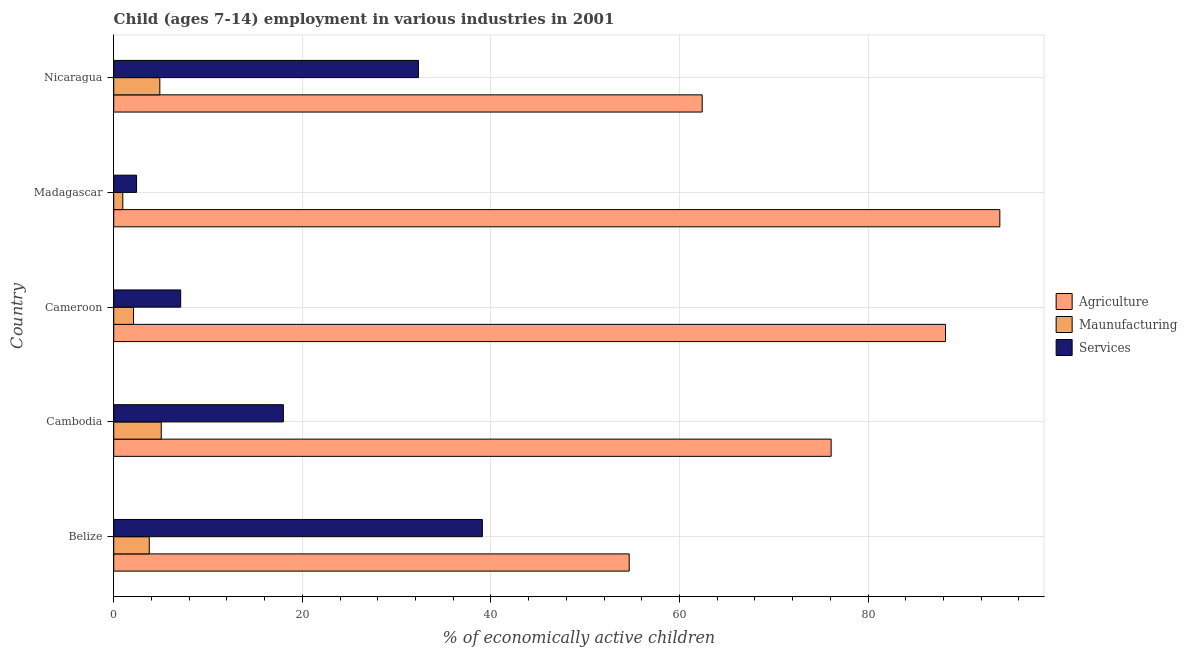Are the number of bars per tick equal to the number of legend labels?
Give a very brief answer. Yes. What is the label of the 2nd group of bars from the top?
Give a very brief answer. Madagascar. What is the percentage of economically active children in services in Belize?
Your response must be concise. 39.09. Across all countries, what is the maximum percentage of economically active children in manufacturing?
Offer a terse response. 5.04. Across all countries, what is the minimum percentage of economically active children in agriculture?
Your answer should be compact. 54.66. In which country was the percentage of economically active children in agriculture maximum?
Provide a succinct answer. Madagascar. In which country was the percentage of economically active children in manufacturing minimum?
Your answer should be very brief. Madagascar. What is the total percentage of economically active children in agriculture in the graph?
Keep it short and to the point. 375.33. What is the difference between the percentage of economically active children in agriculture in Belize and that in Nicaragua?
Give a very brief answer. -7.74. What is the difference between the percentage of economically active children in manufacturing in Cambodia and the percentage of economically active children in agriculture in Belize?
Ensure brevity in your answer.  -49.62. What is the average percentage of economically active children in agriculture per country?
Ensure brevity in your answer.  75.07. What is the difference between the percentage of economically active children in agriculture and percentage of economically active children in manufacturing in Cambodia?
Your response must be concise. 71.04. In how many countries, is the percentage of economically active children in services greater than 24 %?
Keep it short and to the point. 2. What is the ratio of the percentage of economically active children in agriculture in Cambodia to that in Nicaragua?
Make the answer very short. 1.22. Is the percentage of economically active children in manufacturing in Cambodia less than that in Cameroon?
Offer a terse response. No. What is the difference between the highest and the second highest percentage of economically active children in manufacturing?
Keep it short and to the point. 0.15. What is the difference between the highest and the lowest percentage of economically active children in agriculture?
Make the answer very short. 39.31. In how many countries, is the percentage of economically active children in manufacturing greater than the average percentage of economically active children in manufacturing taken over all countries?
Your answer should be compact. 3. Is the sum of the percentage of economically active children in agriculture in Belize and Nicaragua greater than the maximum percentage of economically active children in manufacturing across all countries?
Keep it short and to the point. Yes. What does the 2nd bar from the top in Cameroon represents?
Provide a short and direct response. Maunufacturing. What does the 1st bar from the bottom in Cambodia represents?
Give a very brief answer. Agriculture. Are all the bars in the graph horizontal?
Provide a short and direct response. Yes. How many countries are there in the graph?
Offer a terse response. 5. Does the graph contain any zero values?
Your answer should be compact. No. Does the graph contain grids?
Provide a short and direct response. Yes. How many legend labels are there?
Your answer should be very brief. 3. What is the title of the graph?
Ensure brevity in your answer.  Child (ages 7-14) employment in various industries in 2001. Does "Labor Market" appear as one of the legend labels in the graph?
Provide a succinct answer. No. What is the label or title of the X-axis?
Offer a very short reply. % of economically active children. What is the label or title of the Y-axis?
Offer a terse response. Country. What is the % of economically active children of Agriculture in Belize?
Offer a very short reply. 54.66. What is the % of economically active children of Maunufacturing in Belize?
Keep it short and to the point. 3.77. What is the % of economically active children of Services in Belize?
Provide a succinct answer. 39.09. What is the % of economically active children of Agriculture in Cambodia?
Provide a short and direct response. 76.08. What is the % of economically active children of Maunufacturing in Cambodia?
Give a very brief answer. 5.04. What is the % of economically active children in Services in Cambodia?
Offer a very short reply. 17.99. What is the % of economically active children of Agriculture in Cameroon?
Give a very brief answer. 88.21. What is the % of economically active children of Services in Cameroon?
Offer a terse response. 7.1. What is the % of economically active children of Agriculture in Madagascar?
Provide a short and direct response. 93.97. What is the % of economically active children of Services in Madagascar?
Give a very brief answer. 2.42. What is the % of economically active children in Agriculture in Nicaragua?
Make the answer very short. 62.41. What is the % of economically active children in Maunufacturing in Nicaragua?
Offer a very short reply. 4.89. What is the % of economically active children in Services in Nicaragua?
Your response must be concise. 32.31. Across all countries, what is the maximum % of economically active children of Agriculture?
Your answer should be very brief. 93.97. Across all countries, what is the maximum % of economically active children in Maunufacturing?
Your answer should be very brief. 5.04. Across all countries, what is the maximum % of economically active children in Services?
Your response must be concise. 39.09. Across all countries, what is the minimum % of economically active children of Agriculture?
Your answer should be very brief. 54.66. Across all countries, what is the minimum % of economically active children of Maunufacturing?
Keep it short and to the point. 0.96. Across all countries, what is the minimum % of economically active children of Services?
Offer a very short reply. 2.42. What is the total % of economically active children in Agriculture in the graph?
Your answer should be compact. 375.33. What is the total % of economically active children in Maunufacturing in the graph?
Offer a very short reply. 16.76. What is the total % of economically active children of Services in the graph?
Your answer should be very brief. 98.92. What is the difference between the % of economically active children in Agriculture in Belize and that in Cambodia?
Your response must be concise. -21.42. What is the difference between the % of economically active children in Maunufacturing in Belize and that in Cambodia?
Provide a succinct answer. -1.27. What is the difference between the % of economically active children of Services in Belize and that in Cambodia?
Keep it short and to the point. 21.1. What is the difference between the % of economically active children in Agriculture in Belize and that in Cameroon?
Your answer should be very brief. -33.55. What is the difference between the % of economically active children in Maunufacturing in Belize and that in Cameroon?
Your response must be concise. 1.67. What is the difference between the % of economically active children in Services in Belize and that in Cameroon?
Ensure brevity in your answer.  31.99. What is the difference between the % of economically active children of Agriculture in Belize and that in Madagascar?
Keep it short and to the point. -39.31. What is the difference between the % of economically active children in Maunufacturing in Belize and that in Madagascar?
Make the answer very short. 2.81. What is the difference between the % of economically active children in Services in Belize and that in Madagascar?
Make the answer very short. 36.67. What is the difference between the % of economically active children of Agriculture in Belize and that in Nicaragua?
Your answer should be compact. -7.74. What is the difference between the % of economically active children in Maunufacturing in Belize and that in Nicaragua?
Your answer should be compact. -1.12. What is the difference between the % of economically active children in Services in Belize and that in Nicaragua?
Keep it short and to the point. 6.78. What is the difference between the % of economically active children in Agriculture in Cambodia and that in Cameroon?
Offer a terse response. -12.13. What is the difference between the % of economically active children of Maunufacturing in Cambodia and that in Cameroon?
Provide a succinct answer. 2.94. What is the difference between the % of economically active children in Services in Cambodia and that in Cameroon?
Provide a succinct answer. 10.89. What is the difference between the % of economically active children in Agriculture in Cambodia and that in Madagascar?
Give a very brief answer. -17.89. What is the difference between the % of economically active children of Maunufacturing in Cambodia and that in Madagascar?
Give a very brief answer. 4.08. What is the difference between the % of economically active children of Services in Cambodia and that in Madagascar?
Keep it short and to the point. 15.57. What is the difference between the % of economically active children in Agriculture in Cambodia and that in Nicaragua?
Offer a very short reply. 13.67. What is the difference between the % of economically active children in Maunufacturing in Cambodia and that in Nicaragua?
Ensure brevity in your answer.  0.15. What is the difference between the % of economically active children of Services in Cambodia and that in Nicaragua?
Offer a very short reply. -14.32. What is the difference between the % of economically active children in Agriculture in Cameroon and that in Madagascar?
Your answer should be compact. -5.76. What is the difference between the % of economically active children in Maunufacturing in Cameroon and that in Madagascar?
Your response must be concise. 1.14. What is the difference between the % of economically active children of Services in Cameroon and that in Madagascar?
Your response must be concise. 4.68. What is the difference between the % of economically active children of Agriculture in Cameroon and that in Nicaragua?
Your answer should be very brief. 25.8. What is the difference between the % of economically active children of Maunufacturing in Cameroon and that in Nicaragua?
Provide a succinct answer. -2.79. What is the difference between the % of economically active children in Services in Cameroon and that in Nicaragua?
Keep it short and to the point. -25.21. What is the difference between the % of economically active children in Agriculture in Madagascar and that in Nicaragua?
Provide a succinct answer. 31.56. What is the difference between the % of economically active children of Maunufacturing in Madagascar and that in Nicaragua?
Make the answer very short. -3.93. What is the difference between the % of economically active children of Services in Madagascar and that in Nicaragua?
Your answer should be very brief. -29.89. What is the difference between the % of economically active children in Agriculture in Belize and the % of economically active children in Maunufacturing in Cambodia?
Provide a short and direct response. 49.62. What is the difference between the % of economically active children of Agriculture in Belize and the % of economically active children of Services in Cambodia?
Provide a short and direct response. 36.67. What is the difference between the % of economically active children in Maunufacturing in Belize and the % of economically active children in Services in Cambodia?
Provide a short and direct response. -14.22. What is the difference between the % of economically active children of Agriculture in Belize and the % of economically active children of Maunufacturing in Cameroon?
Provide a short and direct response. 52.56. What is the difference between the % of economically active children of Agriculture in Belize and the % of economically active children of Services in Cameroon?
Provide a succinct answer. 47.56. What is the difference between the % of economically active children in Maunufacturing in Belize and the % of economically active children in Services in Cameroon?
Your response must be concise. -3.33. What is the difference between the % of economically active children of Agriculture in Belize and the % of economically active children of Maunufacturing in Madagascar?
Keep it short and to the point. 53.7. What is the difference between the % of economically active children in Agriculture in Belize and the % of economically active children in Services in Madagascar?
Provide a succinct answer. 52.24. What is the difference between the % of economically active children in Maunufacturing in Belize and the % of economically active children in Services in Madagascar?
Make the answer very short. 1.35. What is the difference between the % of economically active children of Agriculture in Belize and the % of economically active children of Maunufacturing in Nicaragua?
Give a very brief answer. 49.78. What is the difference between the % of economically active children in Agriculture in Belize and the % of economically active children in Services in Nicaragua?
Offer a terse response. 22.35. What is the difference between the % of economically active children of Maunufacturing in Belize and the % of economically active children of Services in Nicaragua?
Offer a very short reply. -28.54. What is the difference between the % of economically active children of Agriculture in Cambodia and the % of economically active children of Maunufacturing in Cameroon?
Ensure brevity in your answer.  73.98. What is the difference between the % of economically active children of Agriculture in Cambodia and the % of economically active children of Services in Cameroon?
Your answer should be compact. 68.98. What is the difference between the % of economically active children in Maunufacturing in Cambodia and the % of economically active children in Services in Cameroon?
Provide a short and direct response. -2.06. What is the difference between the % of economically active children of Agriculture in Cambodia and the % of economically active children of Maunufacturing in Madagascar?
Your answer should be very brief. 75.12. What is the difference between the % of economically active children of Agriculture in Cambodia and the % of economically active children of Services in Madagascar?
Provide a short and direct response. 73.66. What is the difference between the % of economically active children in Maunufacturing in Cambodia and the % of economically active children in Services in Madagascar?
Your answer should be very brief. 2.62. What is the difference between the % of economically active children of Agriculture in Cambodia and the % of economically active children of Maunufacturing in Nicaragua?
Keep it short and to the point. 71.19. What is the difference between the % of economically active children of Agriculture in Cambodia and the % of economically active children of Services in Nicaragua?
Your response must be concise. 43.77. What is the difference between the % of economically active children of Maunufacturing in Cambodia and the % of economically active children of Services in Nicaragua?
Make the answer very short. -27.27. What is the difference between the % of economically active children in Agriculture in Cameroon and the % of economically active children in Maunufacturing in Madagascar?
Give a very brief answer. 87.25. What is the difference between the % of economically active children in Agriculture in Cameroon and the % of economically active children in Services in Madagascar?
Provide a succinct answer. 85.79. What is the difference between the % of economically active children in Maunufacturing in Cameroon and the % of economically active children in Services in Madagascar?
Provide a short and direct response. -0.32. What is the difference between the % of economically active children of Agriculture in Cameroon and the % of economically active children of Maunufacturing in Nicaragua?
Your answer should be compact. 83.32. What is the difference between the % of economically active children of Agriculture in Cameroon and the % of economically active children of Services in Nicaragua?
Provide a short and direct response. 55.9. What is the difference between the % of economically active children in Maunufacturing in Cameroon and the % of economically active children in Services in Nicaragua?
Provide a short and direct response. -30.21. What is the difference between the % of economically active children in Agriculture in Madagascar and the % of economically active children in Maunufacturing in Nicaragua?
Offer a terse response. 89.08. What is the difference between the % of economically active children in Agriculture in Madagascar and the % of economically active children in Services in Nicaragua?
Provide a succinct answer. 61.66. What is the difference between the % of economically active children of Maunufacturing in Madagascar and the % of economically active children of Services in Nicaragua?
Give a very brief answer. -31.35. What is the average % of economically active children in Agriculture per country?
Give a very brief answer. 75.07. What is the average % of economically active children of Maunufacturing per country?
Offer a very short reply. 3.35. What is the average % of economically active children of Services per country?
Your answer should be very brief. 19.78. What is the difference between the % of economically active children of Agriculture and % of economically active children of Maunufacturing in Belize?
Keep it short and to the point. 50.9. What is the difference between the % of economically active children in Agriculture and % of economically active children in Services in Belize?
Your answer should be very brief. 15.57. What is the difference between the % of economically active children of Maunufacturing and % of economically active children of Services in Belize?
Provide a short and direct response. -35.33. What is the difference between the % of economically active children in Agriculture and % of economically active children in Maunufacturing in Cambodia?
Your answer should be very brief. 71.04. What is the difference between the % of economically active children in Agriculture and % of economically active children in Services in Cambodia?
Give a very brief answer. 58.09. What is the difference between the % of economically active children in Maunufacturing and % of economically active children in Services in Cambodia?
Ensure brevity in your answer.  -12.95. What is the difference between the % of economically active children of Agriculture and % of economically active children of Maunufacturing in Cameroon?
Offer a terse response. 86.11. What is the difference between the % of economically active children in Agriculture and % of economically active children in Services in Cameroon?
Offer a very short reply. 81.11. What is the difference between the % of economically active children of Maunufacturing and % of economically active children of Services in Cameroon?
Make the answer very short. -5. What is the difference between the % of economically active children in Agriculture and % of economically active children in Maunufacturing in Madagascar?
Ensure brevity in your answer.  93.01. What is the difference between the % of economically active children of Agriculture and % of economically active children of Services in Madagascar?
Give a very brief answer. 91.55. What is the difference between the % of economically active children in Maunufacturing and % of economically active children in Services in Madagascar?
Ensure brevity in your answer.  -1.46. What is the difference between the % of economically active children in Agriculture and % of economically active children in Maunufacturing in Nicaragua?
Your answer should be compact. 57.52. What is the difference between the % of economically active children of Agriculture and % of economically active children of Services in Nicaragua?
Make the answer very short. 30.09. What is the difference between the % of economically active children in Maunufacturing and % of economically active children in Services in Nicaragua?
Provide a short and direct response. -27.42. What is the ratio of the % of economically active children in Agriculture in Belize to that in Cambodia?
Keep it short and to the point. 0.72. What is the ratio of the % of economically active children of Maunufacturing in Belize to that in Cambodia?
Provide a short and direct response. 0.75. What is the ratio of the % of economically active children in Services in Belize to that in Cambodia?
Provide a succinct answer. 2.17. What is the ratio of the % of economically active children in Agriculture in Belize to that in Cameroon?
Keep it short and to the point. 0.62. What is the ratio of the % of economically active children of Maunufacturing in Belize to that in Cameroon?
Make the answer very short. 1.79. What is the ratio of the % of economically active children in Services in Belize to that in Cameroon?
Provide a succinct answer. 5.51. What is the ratio of the % of economically active children in Agriculture in Belize to that in Madagascar?
Make the answer very short. 0.58. What is the ratio of the % of economically active children of Maunufacturing in Belize to that in Madagascar?
Your response must be concise. 3.92. What is the ratio of the % of economically active children of Services in Belize to that in Madagascar?
Keep it short and to the point. 16.15. What is the ratio of the % of economically active children of Agriculture in Belize to that in Nicaragua?
Give a very brief answer. 0.88. What is the ratio of the % of economically active children in Maunufacturing in Belize to that in Nicaragua?
Keep it short and to the point. 0.77. What is the ratio of the % of economically active children in Services in Belize to that in Nicaragua?
Your response must be concise. 1.21. What is the ratio of the % of economically active children in Agriculture in Cambodia to that in Cameroon?
Give a very brief answer. 0.86. What is the ratio of the % of economically active children in Services in Cambodia to that in Cameroon?
Give a very brief answer. 2.53. What is the ratio of the % of economically active children of Agriculture in Cambodia to that in Madagascar?
Ensure brevity in your answer.  0.81. What is the ratio of the % of economically active children in Maunufacturing in Cambodia to that in Madagascar?
Provide a short and direct response. 5.25. What is the ratio of the % of economically active children in Services in Cambodia to that in Madagascar?
Your answer should be very brief. 7.43. What is the ratio of the % of economically active children of Agriculture in Cambodia to that in Nicaragua?
Provide a succinct answer. 1.22. What is the ratio of the % of economically active children in Maunufacturing in Cambodia to that in Nicaragua?
Provide a succinct answer. 1.03. What is the ratio of the % of economically active children of Services in Cambodia to that in Nicaragua?
Your answer should be very brief. 0.56. What is the ratio of the % of economically active children in Agriculture in Cameroon to that in Madagascar?
Offer a very short reply. 0.94. What is the ratio of the % of economically active children in Maunufacturing in Cameroon to that in Madagascar?
Offer a very short reply. 2.19. What is the ratio of the % of economically active children of Services in Cameroon to that in Madagascar?
Your answer should be compact. 2.93. What is the ratio of the % of economically active children in Agriculture in Cameroon to that in Nicaragua?
Your answer should be very brief. 1.41. What is the ratio of the % of economically active children of Maunufacturing in Cameroon to that in Nicaragua?
Your response must be concise. 0.43. What is the ratio of the % of economically active children of Services in Cameroon to that in Nicaragua?
Provide a succinct answer. 0.22. What is the ratio of the % of economically active children in Agriculture in Madagascar to that in Nicaragua?
Provide a succinct answer. 1.51. What is the ratio of the % of economically active children in Maunufacturing in Madagascar to that in Nicaragua?
Your answer should be very brief. 0.2. What is the ratio of the % of economically active children in Services in Madagascar to that in Nicaragua?
Give a very brief answer. 0.07. What is the difference between the highest and the second highest % of economically active children of Agriculture?
Make the answer very short. 5.76. What is the difference between the highest and the second highest % of economically active children of Maunufacturing?
Your answer should be very brief. 0.15. What is the difference between the highest and the second highest % of economically active children in Services?
Your answer should be compact. 6.78. What is the difference between the highest and the lowest % of economically active children of Agriculture?
Your answer should be compact. 39.31. What is the difference between the highest and the lowest % of economically active children of Maunufacturing?
Keep it short and to the point. 4.08. What is the difference between the highest and the lowest % of economically active children in Services?
Offer a terse response. 36.67. 